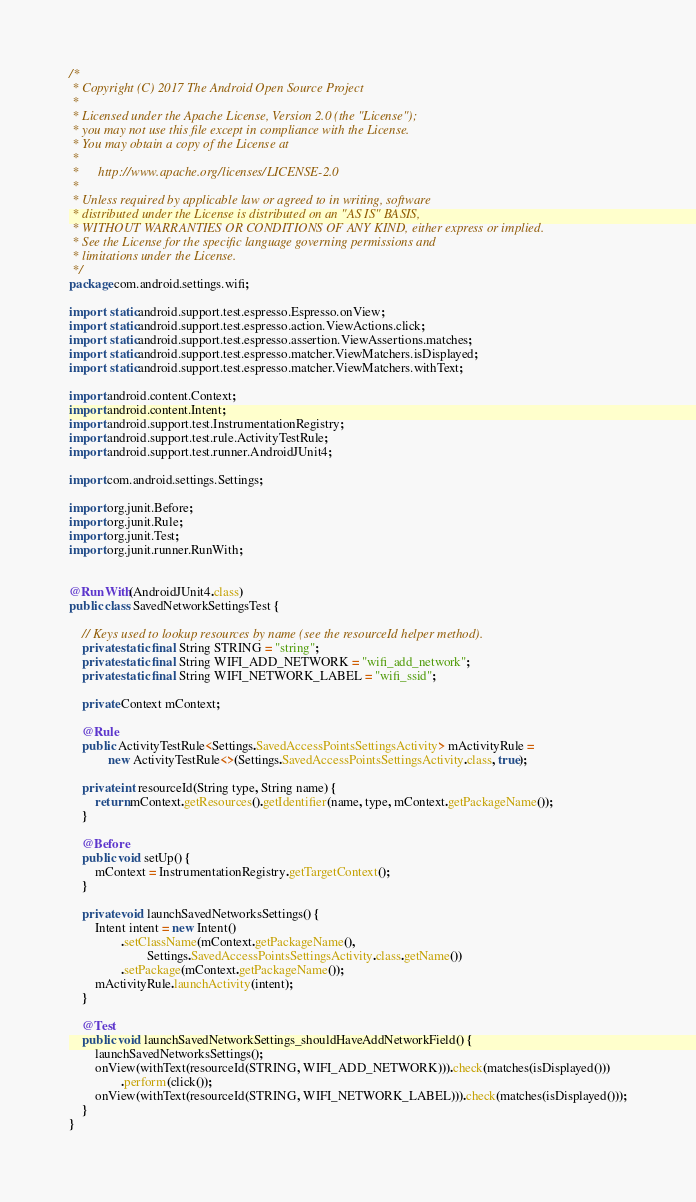<code> <loc_0><loc_0><loc_500><loc_500><_Java_>/*
 * Copyright (C) 2017 The Android Open Source Project
 *
 * Licensed under the Apache License, Version 2.0 (the "License");
 * you may not use this file except in compliance with the License.
 * You may obtain a copy of the License at
 *
 *      http://www.apache.org/licenses/LICENSE-2.0
 *
 * Unless required by applicable law or agreed to in writing, software
 * distributed under the License is distributed on an "AS IS" BASIS,
 * WITHOUT WARRANTIES OR CONDITIONS OF ANY KIND, either express or implied.
 * See the License for the specific language governing permissions and
 * limitations under the License.
 */
package com.android.settings.wifi;

import static android.support.test.espresso.Espresso.onView;
import static android.support.test.espresso.action.ViewActions.click;
import static android.support.test.espresso.assertion.ViewAssertions.matches;
import static android.support.test.espresso.matcher.ViewMatchers.isDisplayed;
import static android.support.test.espresso.matcher.ViewMatchers.withText;

import android.content.Context;
import android.content.Intent;
import android.support.test.InstrumentationRegistry;
import android.support.test.rule.ActivityTestRule;
import android.support.test.runner.AndroidJUnit4;

import com.android.settings.Settings;

import org.junit.Before;
import org.junit.Rule;
import org.junit.Test;
import org.junit.runner.RunWith;


@RunWith(AndroidJUnit4.class)
public class SavedNetworkSettingsTest {

    // Keys used to lookup resources by name (see the resourceId helper method).
    private static final String STRING = "string";
    private static final String WIFI_ADD_NETWORK = "wifi_add_network";
    private static final String WIFI_NETWORK_LABEL = "wifi_ssid";

    private Context mContext;

    @Rule
    public ActivityTestRule<Settings.SavedAccessPointsSettingsActivity> mActivityRule =
            new ActivityTestRule<>(Settings.SavedAccessPointsSettingsActivity.class, true);

    private int resourceId(String type, String name) {
        return mContext.getResources().getIdentifier(name, type, mContext.getPackageName());
    }

    @Before
    public void setUp() {
        mContext = InstrumentationRegistry.getTargetContext();
    }

    private void launchSavedNetworksSettings() {
        Intent intent = new Intent()
                .setClassName(mContext.getPackageName(),
                        Settings.SavedAccessPointsSettingsActivity.class.getName())
                .setPackage(mContext.getPackageName());
        mActivityRule.launchActivity(intent);
    }

    @Test
    public void launchSavedNetworkSettings_shouldHaveAddNetworkField() {
        launchSavedNetworksSettings();
        onView(withText(resourceId(STRING, WIFI_ADD_NETWORK))).check(matches(isDisplayed()))
                .perform(click());
        onView(withText(resourceId(STRING, WIFI_NETWORK_LABEL))).check(matches(isDisplayed()));
    }
}
</code> 